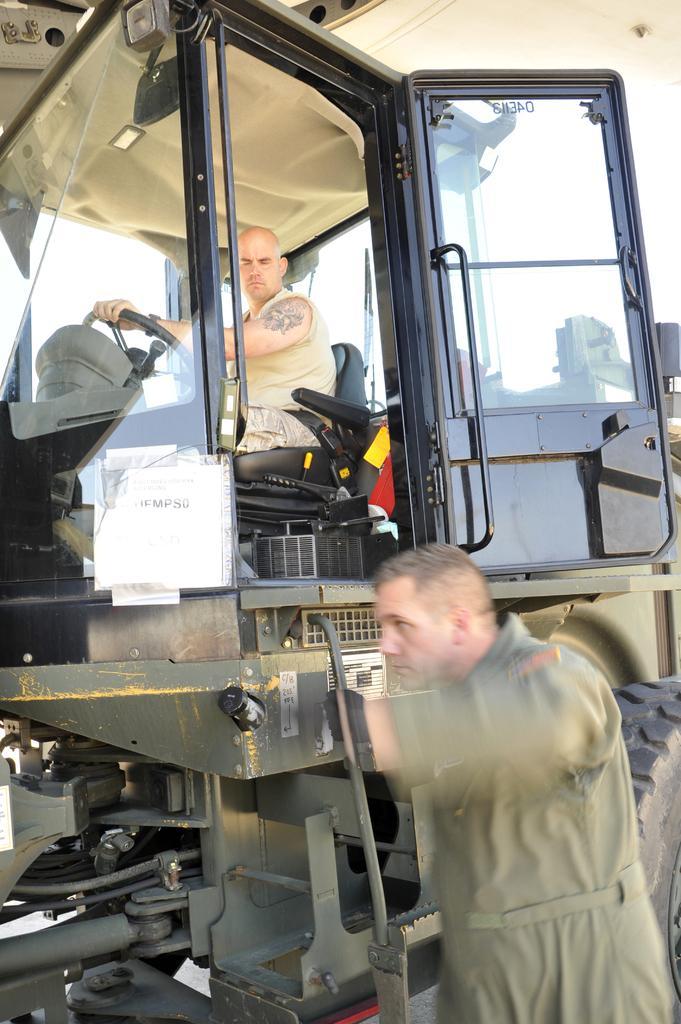In one or two sentences, can you explain what this image depicts? In this image there is a person sitting inside the vehicle. Beside the vehicle there is another person. In the background of the image there is sky. 